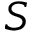<formula> <loc_0><loc_0><loc_500><loc_500>S</formula> 